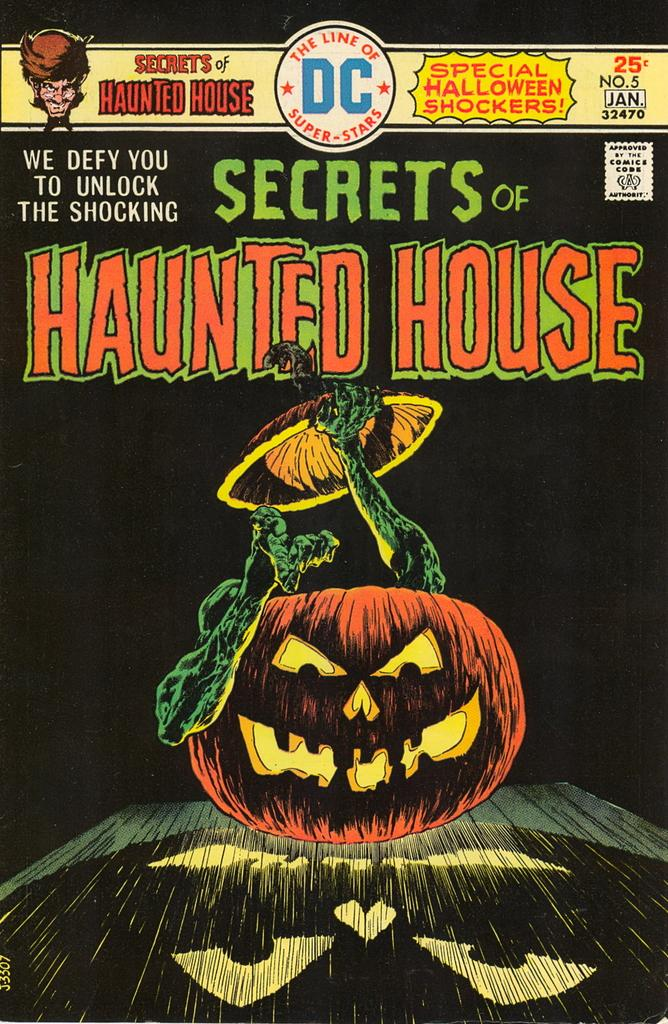What is the color of the poster in the image? The poster is black in the image. What can be found on the poster besides the color? The poster contains text and an image of a pumpkin. What type of animal can be seen in the town on the poster? There is no animal or town depicted on the poster; it features text and an image of a pumpkin. 